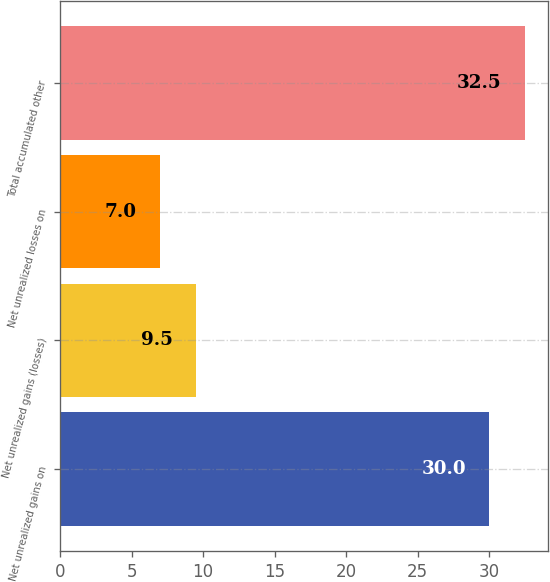<chart> <loc_0><loc_0><loc_500><loc_500><bar_chart><fcel>Net unrealized gains on<fcel>Net unrealized gains (losses)<fcel>Net unrealized losses on<fcel>Total accumulated other<nl><fcel>30<fcel>9.5<fcel>7<fcel>32.5<nl></chart> 